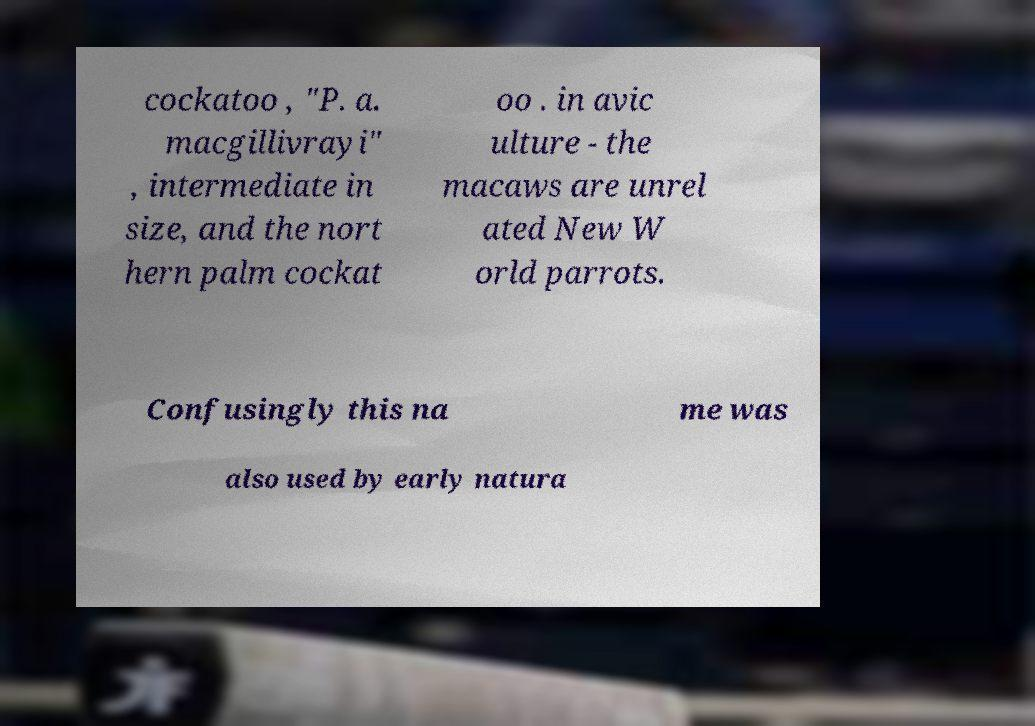Please read and relay the text visible in this image. What does it say? cockatoo , "P. a. macgillivrayi" , intermediate in size, and the nort hern palm cockat oo . in avic ulture - the macaws are unrel ated New W orld parrots. Confusingly this na me was also used by early natura 